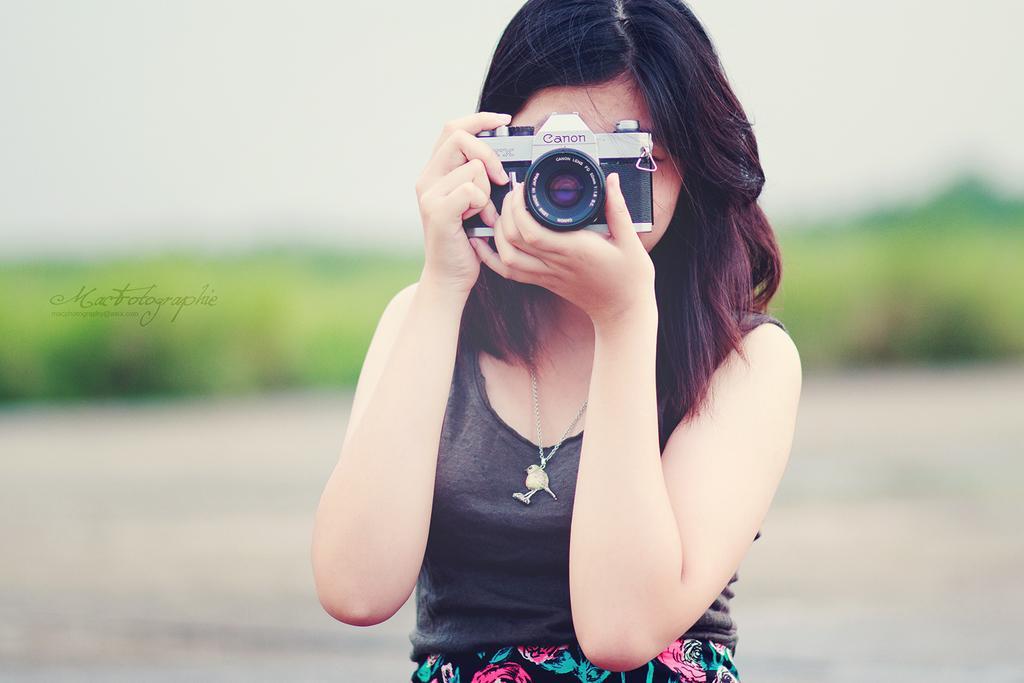Describe this image in one or two sentences. In this picture there is a woman holding a camera in front of her face. She is wearing a black dress and ornament. In the background there are some plants. 